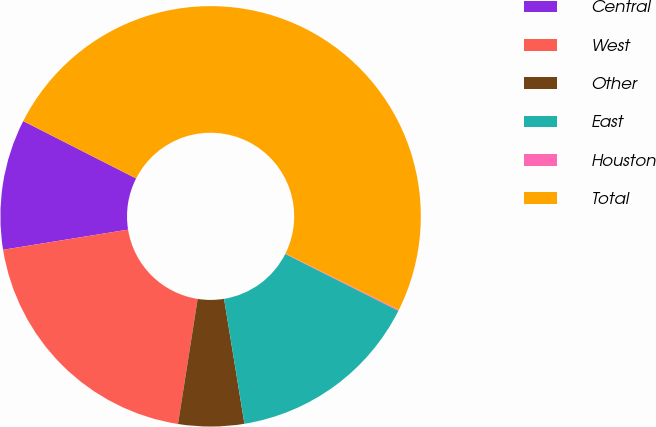Convert chart to OTSL. <chart><loc_0><loc_0><loc_500><loc_500><pie_chart><fcel>Central<fcel>West<fcel>Other<fcel>East<fcel>Houston<fcel>Total<nl><fcel>10.03%<fcel>19.98%<fcel>5.05%<fcel>15.01%<fcel>0.08%<fcel>49.85%<nl></chart> 